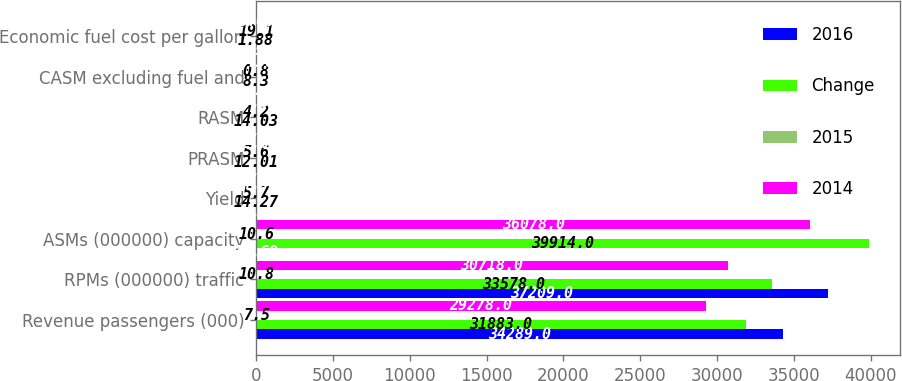Convert chart. <chart><loc_0><loc_0><loc_500><loc_500><stacked_bar_chart><ecel><fcel>Revenue passengers (000)<fcel>RPMs (000000) traffic<fcel>ASMs (000000) capacity<fcel>Yield<fcel>PRASM<fcel>RASM<fcel>CASM excluding fuel and<fcel>Economic fuel cost per gallon<nl><fcel>2016<fcel>34289<fcel>37209<fcel>12.69<fcel>13.45<fcel>11.34<fcel>13.44<fcel>8.23<fcel>1.52<nl><fcel>Change<fcel>31883<fcel>33578<fcel>39914<fcel>14.27<fcel>12.01<fcel>14.03<fcel>8.3<fcel>1.88<nl><fcel>2015<fcel>7.5<fcel>10.8<fcel>10.6<fcel>5.7<fcel>5.6<fcel>4.2<fcel>0.8<fcel>19.1<nl><fcel>2014<fcel>29278<fcel>30718<fcel>36078<fcel>14.91<fcel>12.69<fcel>14.88<fcel>8.36<fcel>3.08<nl></chart> 